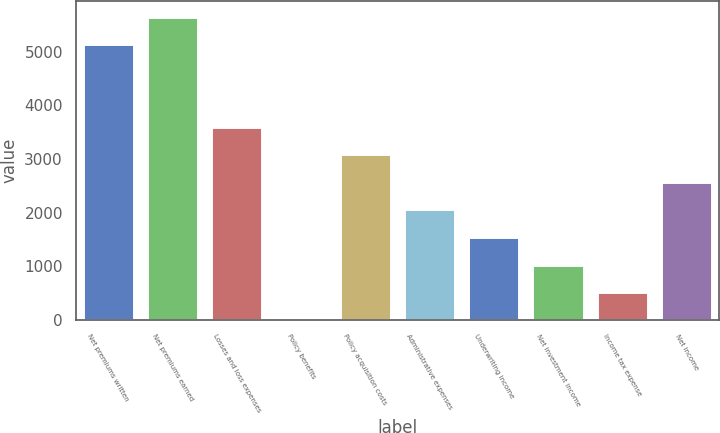<chart> <loc_0><loc_0><loc_500><loc_500><bar_chart><fcel>Net premiums written<fcel>Net premiums earned<fcel>Losses and loss expenses<fcel>Policy benefits<fcel>Policy acquisition costs<fcel>Administrative expenses<fcel>Underwriting income<fcel>Net investment income<fcel>Income tax expense<fcel>Net income<nl><fcel>5145<fcel>5659.3<fcel>3604.1<fcel>4<fcel>3089.8<fcel>2061.2<fcel>1546.9<fcel>1032.6<fcel>518.3<fcel>2575.5<nl></chart> 